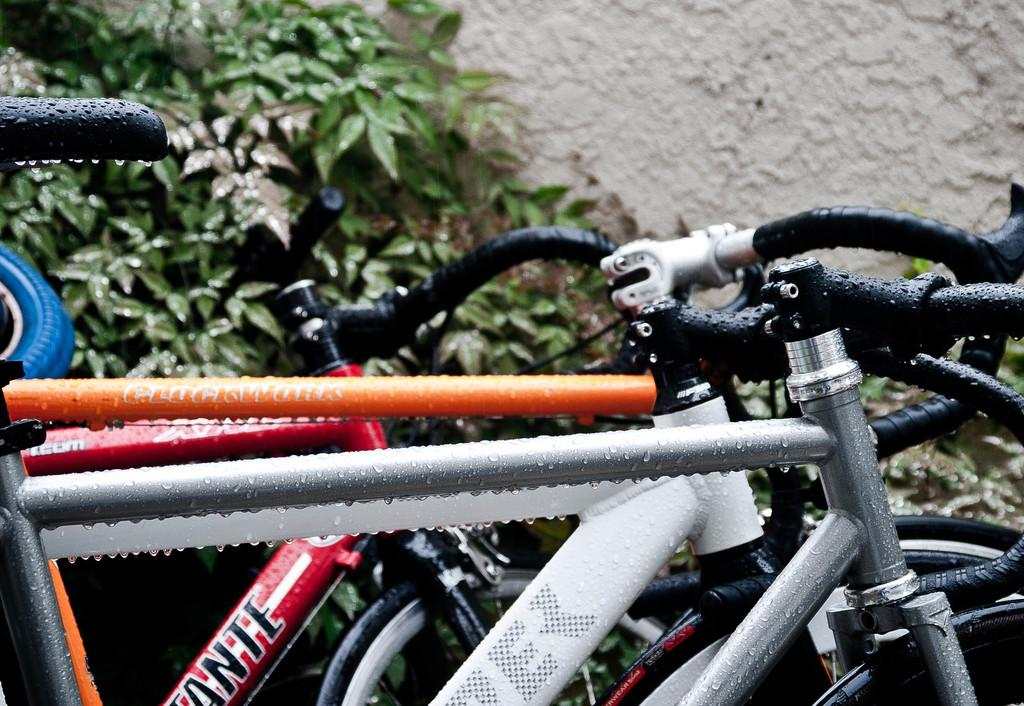What type of vehicles are in the image? There are cycles in the image. What can be seen on the cycles? There are water droplets on the cycles. What is visible in the background of the image? There is a wall in the background of the image. What type of vegetation is near the wall in the background? There are plants near the wall in the background. What type of building is visible in the front of the image? A: There is no building visible in the image; it features cycles with water droplets, a wall, and plants in the background. 